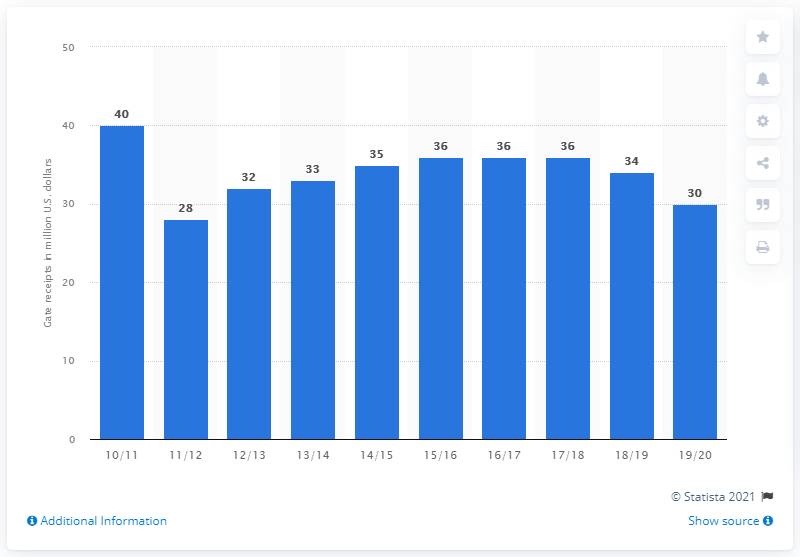Indicate a few pertinent items in this graphic. The gate receipts of the Phoenix Suns in the 2019/20 season were approximately 30 million dollars. 